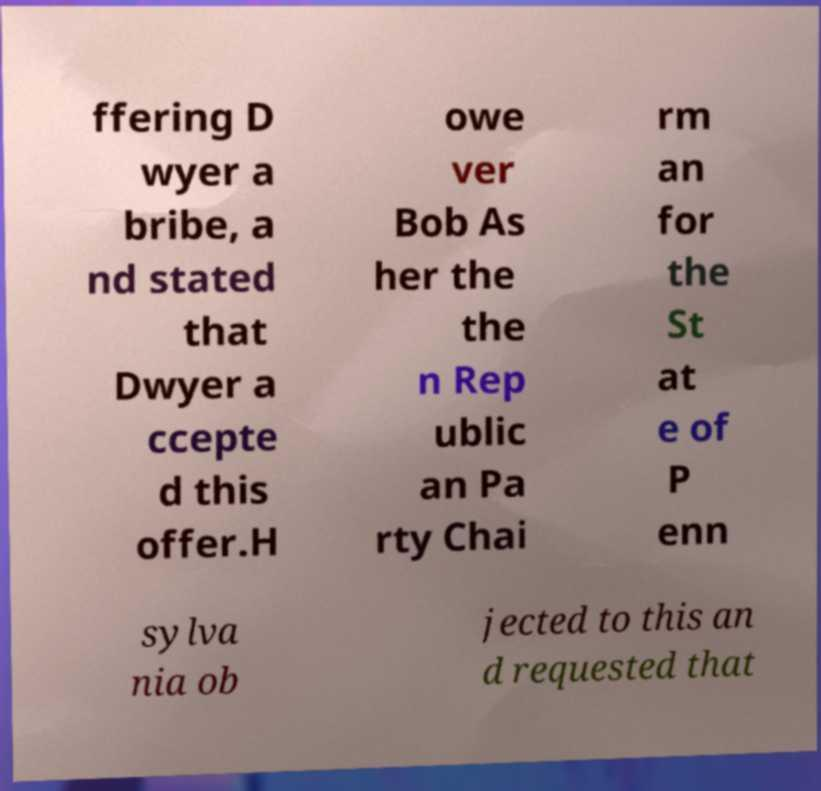Could you extract and type out the text from this image? ffering D wyer a bribe, a nd stated that Dwyer a ccepte d this offer.H owe ver Bob As her the the n Rep ublic an Pa rty Chai rm an for the St at e of P enn sylva nia ob jected to this an d requested that 